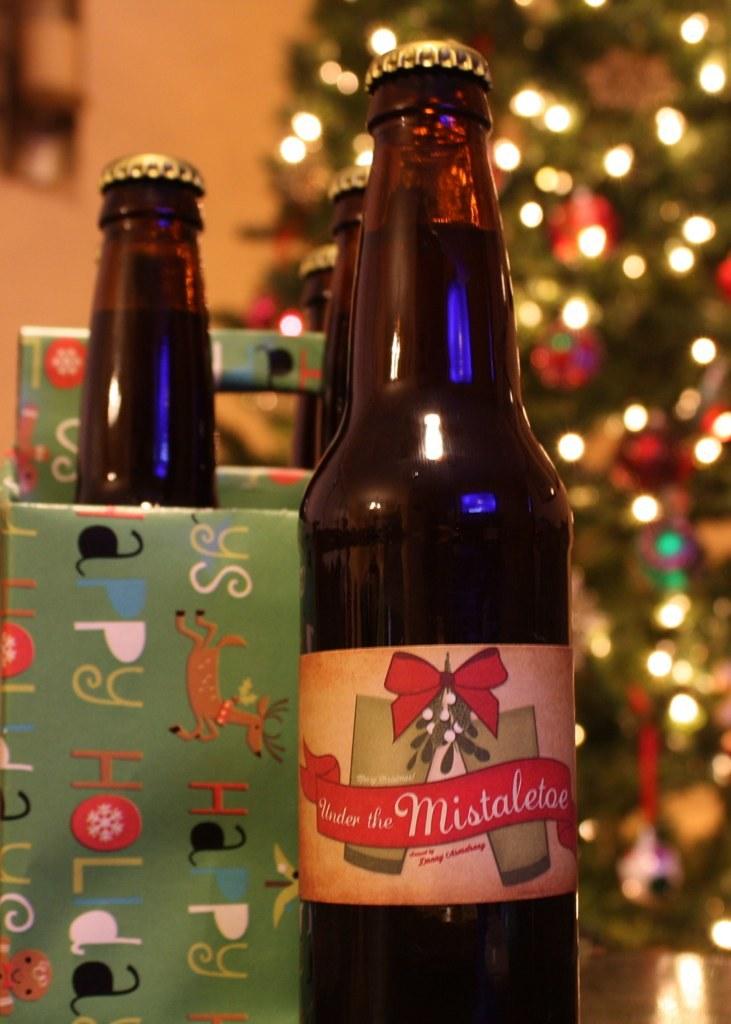What does the beer bottle label say on the red ribbon?
Provide a succinct answer. Under the mistaletoe. What does the wrapping paper repeat over and over again?
Your response must be concise. Happy holidays. 